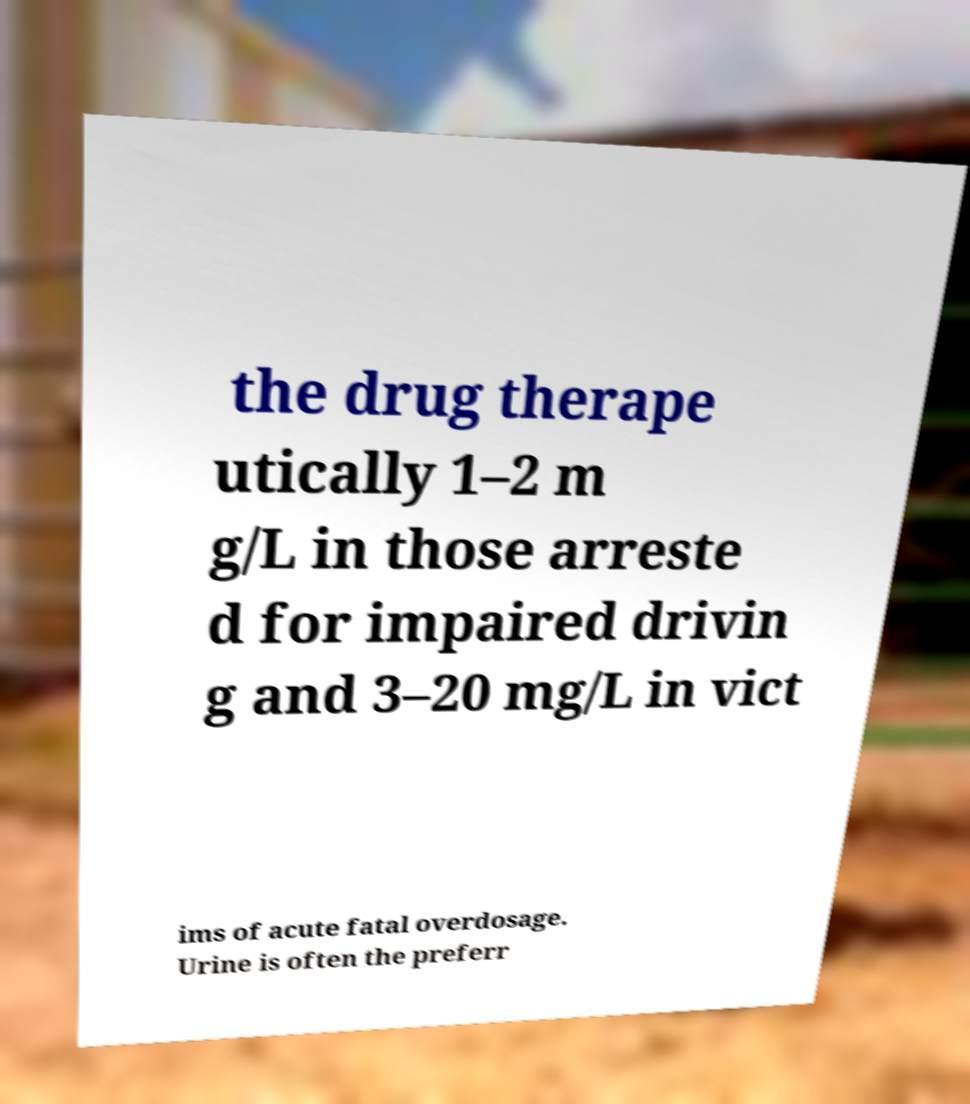Can you accurately transcribe the text from the provided image for me? the drug therape utically 1–2 m g/L in those arreste d for impaired drivin g and 3–20 mg/L in vict ims of acute fatal overdosage. Urine is often the preferr 